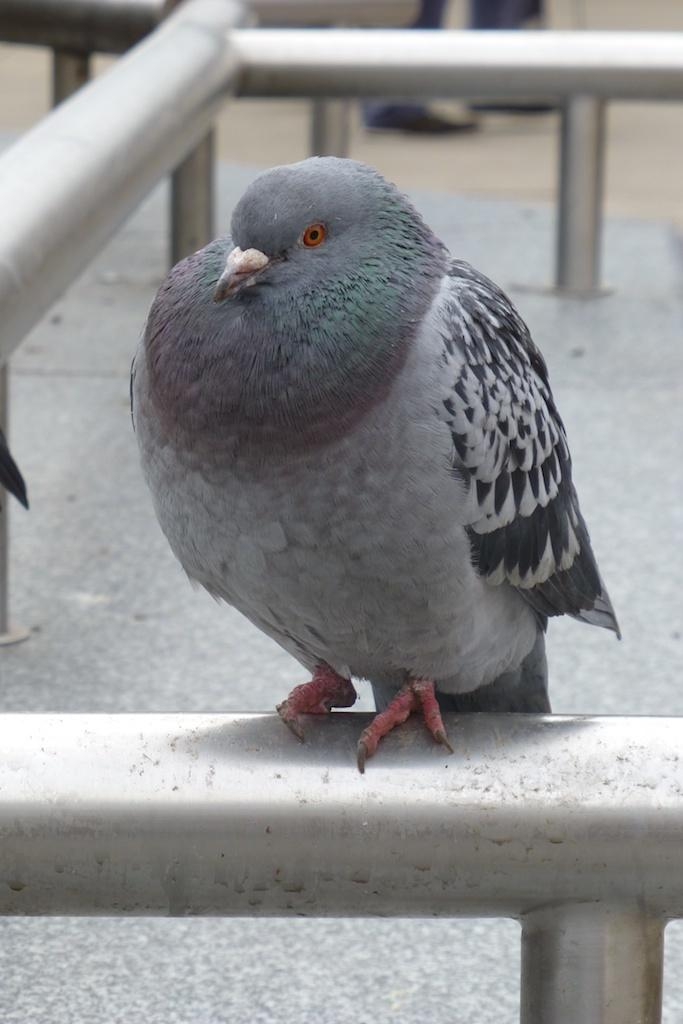What type of animal can be seen in the image? There is a bird in the image. What objects are present in the image besides the bird? There are rods in the image. What hobbies does the bird have in the image? There is no information about the bird's hobbies in the image. Does the bird express any feelings of hate in the image? There is no indication of the bird's emotions, including hate, in the image. 